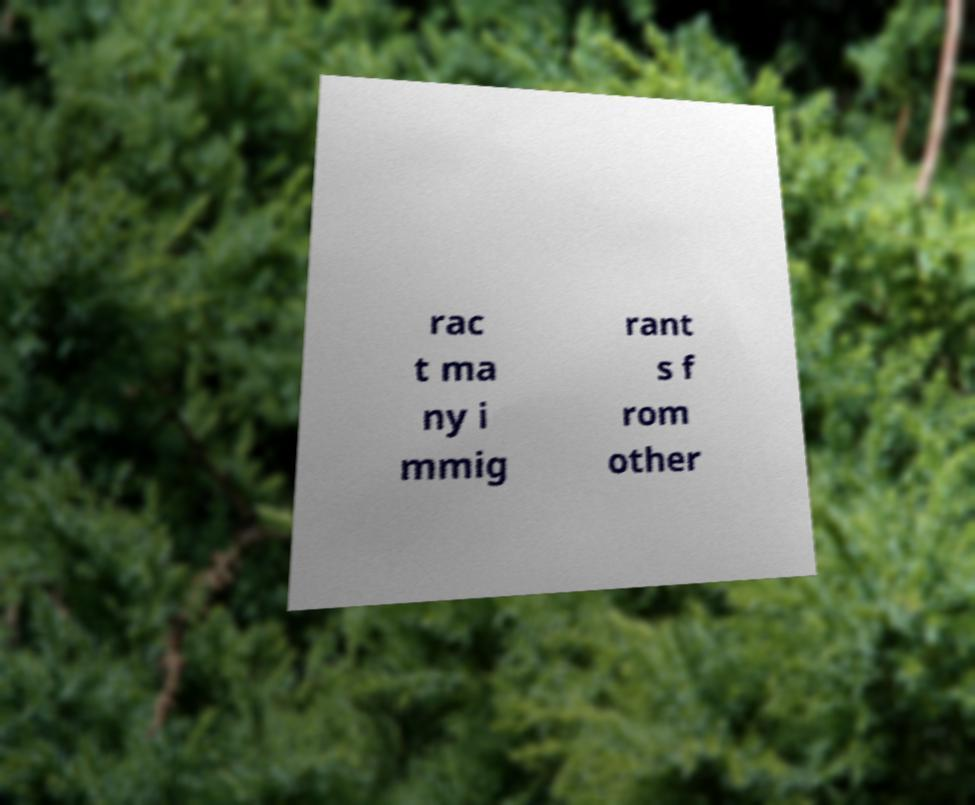Can you accurately transcribe the text from the provided image for me? rac t ma ny i mmig rant s f rom other 